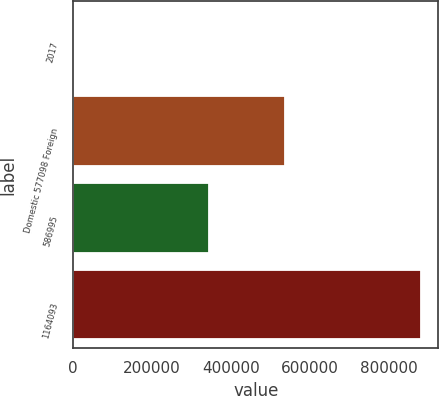<chart> <loc_0><loc_0><loc_500><loc_500><bar_chart><fcel>2017<fcel>Domestic 577098 Foreign<fcel>586995<fcel>1164093<nl><fcel>2016<fcel>536869<fcel>343857<fcel>880726<nl></chart> 